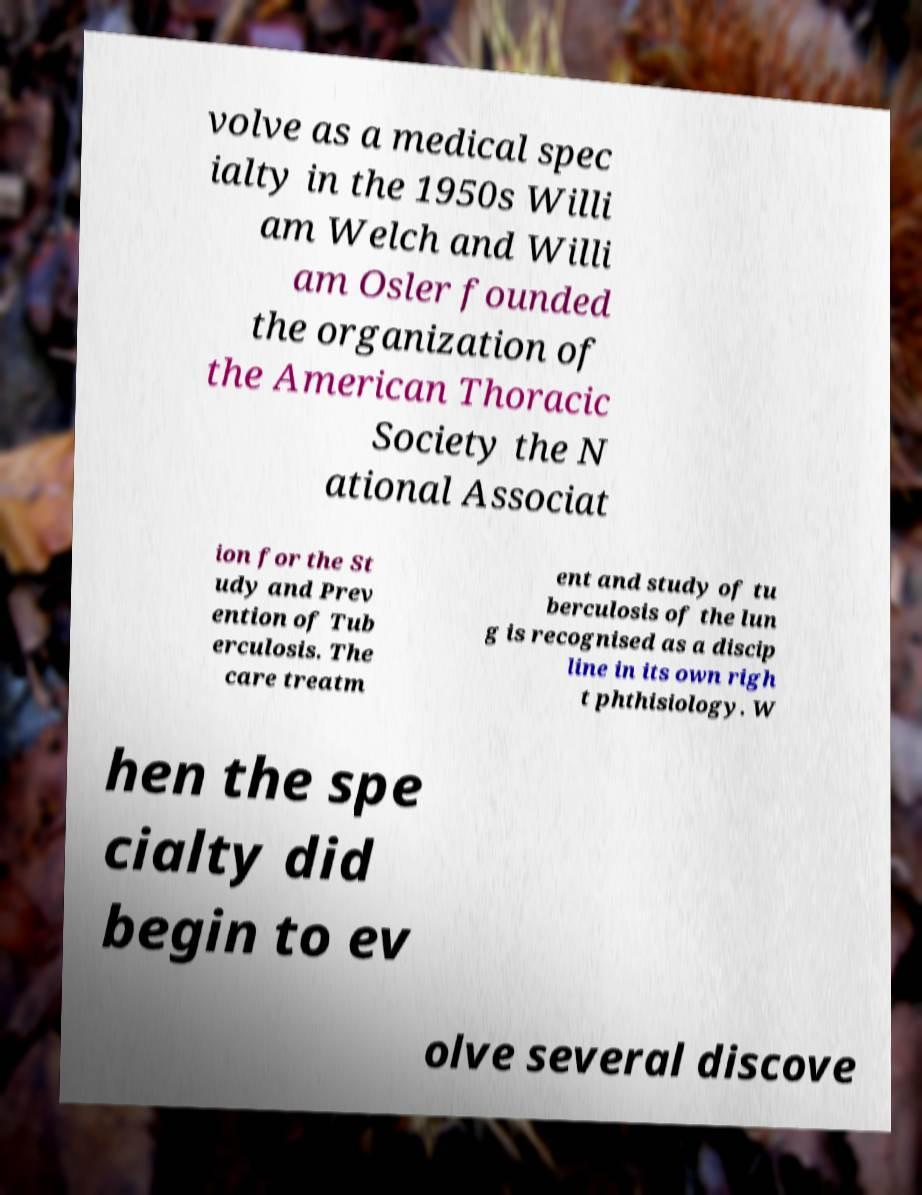For documentation purposes, I need the text within this image transcribed. Could you provide that? volve as a medical spec ialty in the 1950s Willi am Welch and Willi am Osler founded the organization of the American Thoracic Society the N ational Associat ion for the St udy and Prev ention of Tub erculosis. The care treatm ent and study of tu berculosis of the lun g is recognised as a discip line in its own righ t phthisiology. W hen the spe cialty did begin to ev olve several discove 